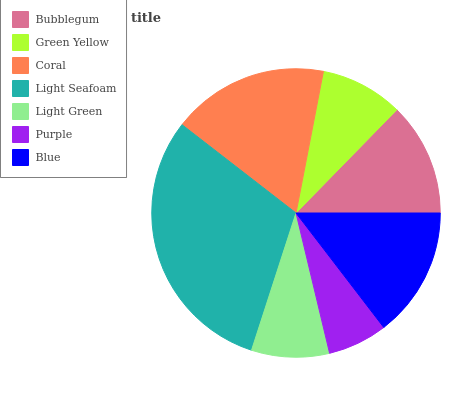Is Purple the minimum?
Answer yes or no. Yes. Is Light Seafoam the maximum?
Answer yes or no. Yes. Is Green Yellow the minimum?
Answer yes or no. No. Is Green Yellow the maximum?
Answer yes or no. No. Is Bubblegum greater than Green Yellow?
Answer yes or no. Yes. Is Green Yellow less than Bubblegum?
Answer yes or no. Yes. Is Green Yellow greater than Bubblegum?
Answer yes or no. No. Is Bubblegum less than Green Yellow?
Answer yes or no. No. Is Bubblegum the high median?
Answer yes or no. Yes. Is Bubblegum the low median?
Answer yes or no. Yes. Is Blue the high median?
Answer yes or no. No. Is Green Yellow the low median?
Answer yes or no. No. 